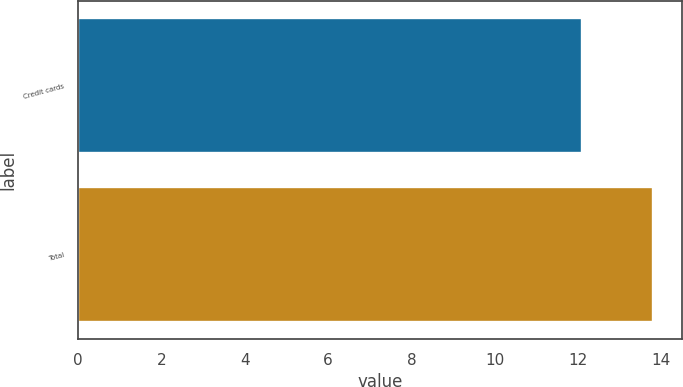Convert chart to OTSL. <chart><loc_0><loc_0><loc_500><loc_500><bar_chart><fcel>Credit cards<fcel>Total<nl><fcel>12.1<fcel>13.8<nl></chart> 